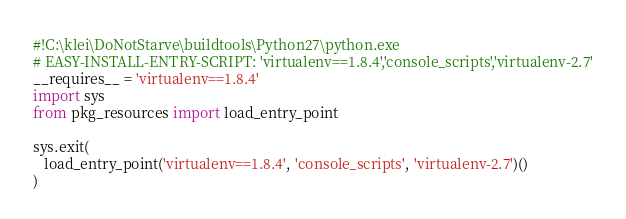Convert code to text. <code><loc_0><loc_0><loc_500><loc_500><_Python_>#!C:\klei\DoNotStarve\buildtools\Python27\python.exe
# EASY-INSTALL-ENTRY-SCRIPT: 'virtualenv==1.8.4','console_scripts','virtualenv-2.7'
__requires__ = 'virtualenv==1.8.4'
import sys
from pkg_resources import load_entry_point

sys.exit(
   load_entry_point('virtualenv==1.8.4', 'console_scripts', 'virtualenv-2.7')()
)
</code> 